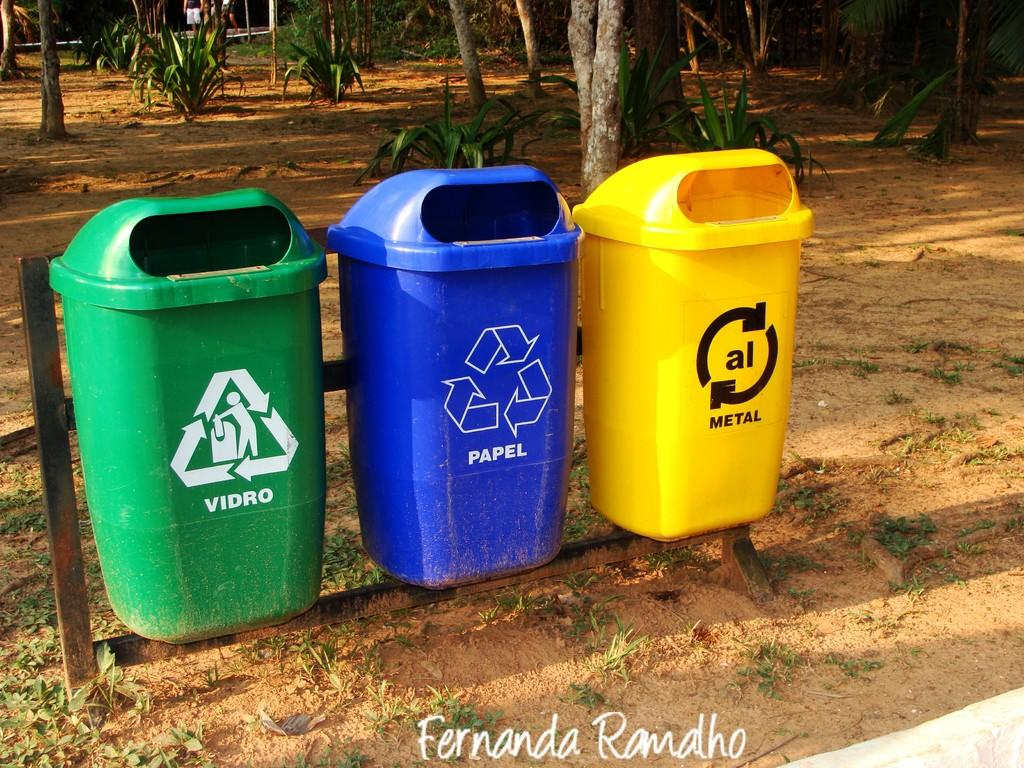<image>
Write a terse but informative summary of the picture. trash cans for recycling paper and other items are hanging on a pipe 